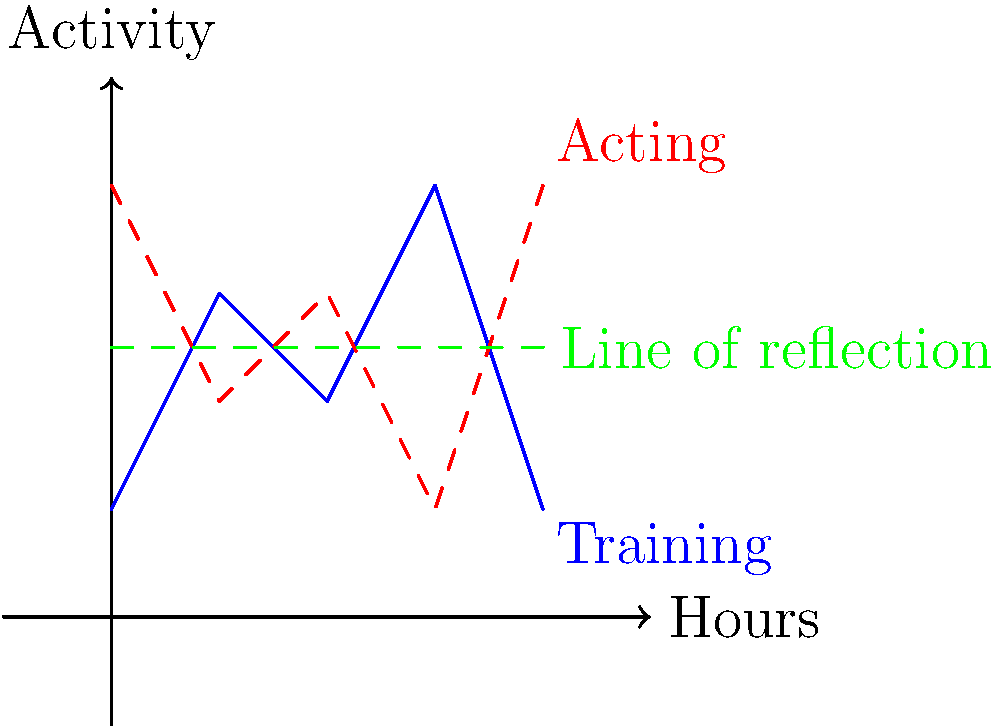The blue line in the graph represents your weekly training schedule as an athlete, with hours on the x-axis and intensity of activity on the y-axis. To create a balanced acting schedule, you decide to reflect this graph over the line $y=2.5$. What is the equation of the line that represents your new acting schedule? To find the equation of the reflected line, we need to follow these steps:

1. The original line (blue) can be described by a series of line segments connecting the points (0,1), (1,3), (2,2), (3,4), and (4,1).

2. When reflecting over the line $y=2.5$, each point $(x,y)$ on the original line will be transformed to $(x, 5-y)$. This is because:
   - The distance of each point from the line of reflection ($y=2.5$) will be preserved.
   - Points above $y=2.5$ will move below it, and vice versa.

3. Reflecting each point:
   - (0,1) becomes (0,4)
   - (1,3) becomes (1,2)
   - (2,2) becomes (2,3)
   - (3,4) becomes (3,1)
   - (4,1) becomes (4,4)

4. The reflected line (red, dashed) connects these new points in the same order.

5. To describe this mathematically, we can use a piecewise function:

   $$f(x) = \begin{cases}
   4-3x & \text{for } 0 \leq x < 1 \\
   2+x & \text{for } 1 \leq x < 2 \\
   3-2x & \text{for } 2 \leq x < 3 \\
   -3+x & \text{for } 3 \leq x \leq 4
   \end{cases}$$

This piecewise function represents the equation of the line for the new acting schedule.
Answer: $$f(x) = \begin{cases}
4-3x & \text{for } 0 \leq x < 1 \\
2+x & \text{for } 1 \leq x < 2 \\
3-2x & \text{for } 2 \leq x < 3 \\
-3+x & \text{for } 3 \leq x \leq 4
\end{cases}$$ 